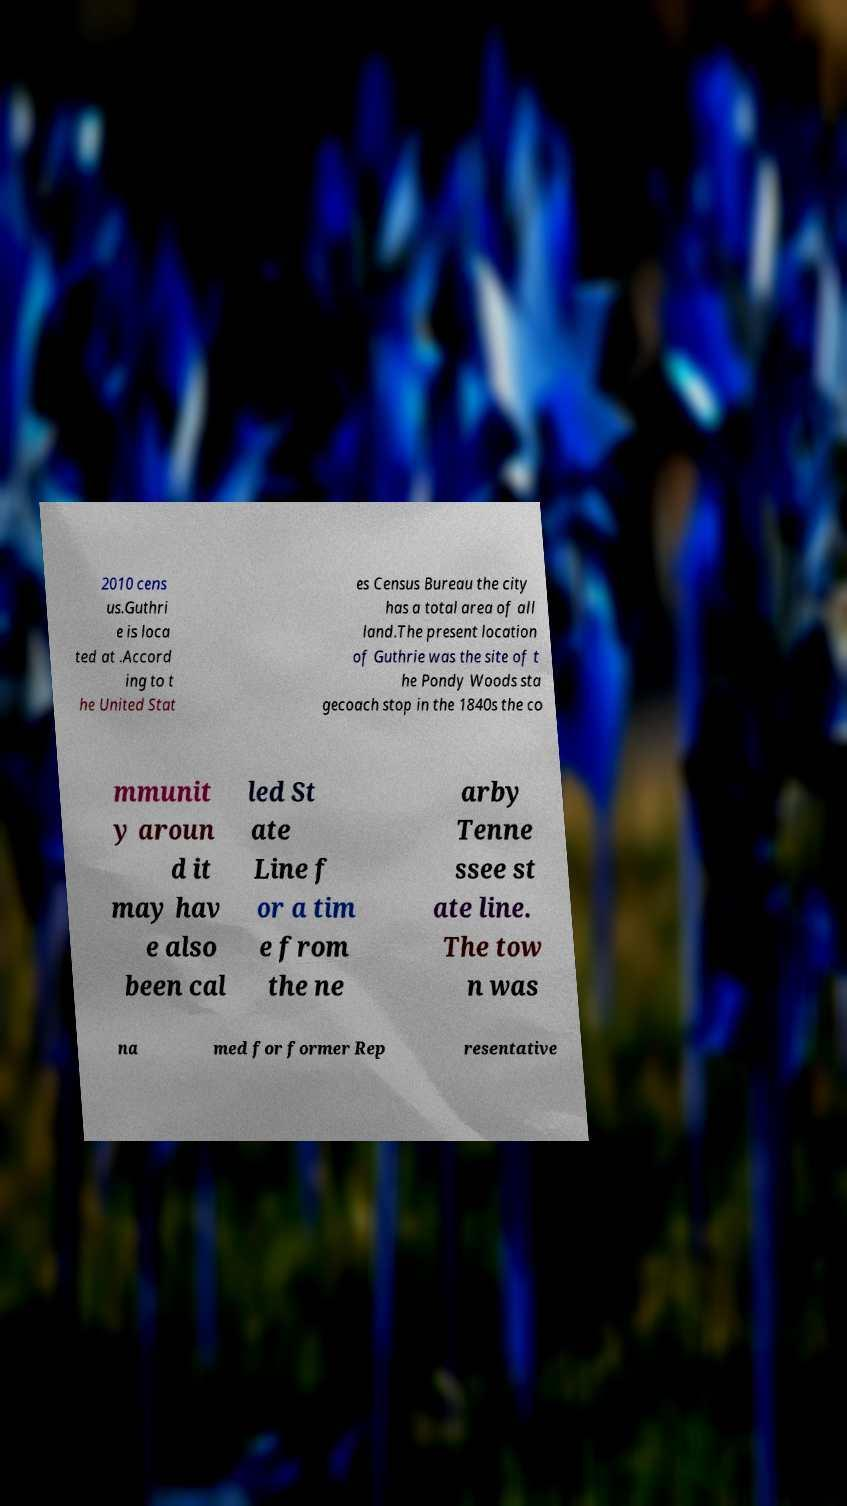Can you read and provide the text displayed in the image?This photo seems to have some interesting text. Can you extract and type it out for me? 2010 cens us.Guthri e is loca ted at .Accord ing to t he United Stat es Census Bureau the city has a total area of all land.The present location of Guthrie was the site of t he Pondy Woods sta gecoach stop in the 1840s the co mmunit y aroun d it may hav e also been cal led St ate Line f or a tim e from the ne arby Tenne ssee st ate line. The tow n was na med for former Rep resentative 